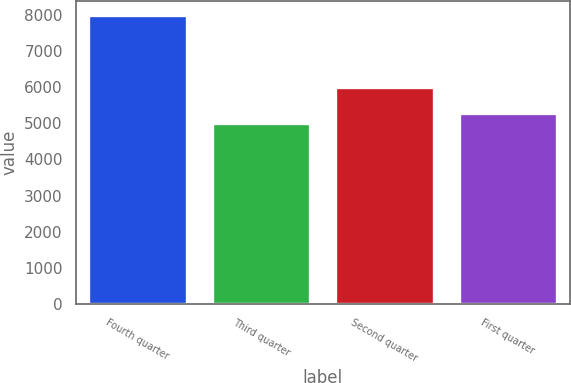Convert chart. <chart><loc_0><loc_0><loc_500><loc_500><bar_chart><fcel>Fourth quarter<fcel>Third quarter<fcel>Second quarter<fcel>First quarter<nl><fcel>8000<fcel>5000<fcel>6000<fcel>5300<nl></chart> 